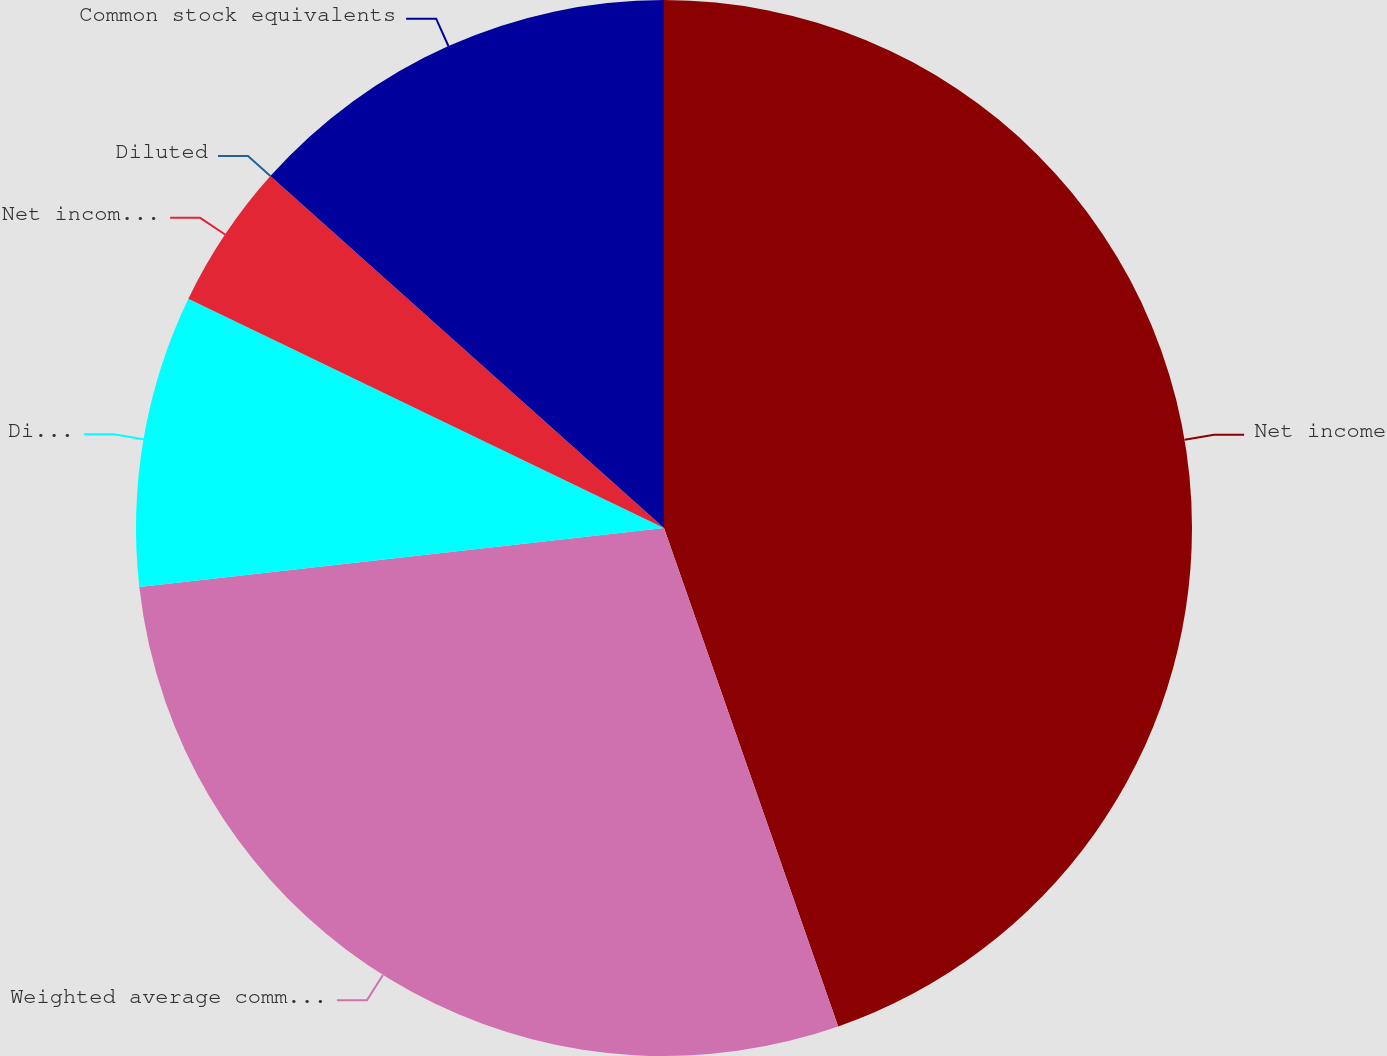<chart> <loc_0><loc_0><loc_500><loc_500><pie_chart><fcel>Net income<fcel>Weighted average common shares<fcel>Dilutive effect of equity<fcel>Net income per share Basic<fcel>Diluted<fcel>Common stock equivalents<nl><fcel>44.65%<fcel>28.57%<fcel>8.93%<fcel>4.46%<fcel>0.0%<fcel>13.39%<nl></chart> 